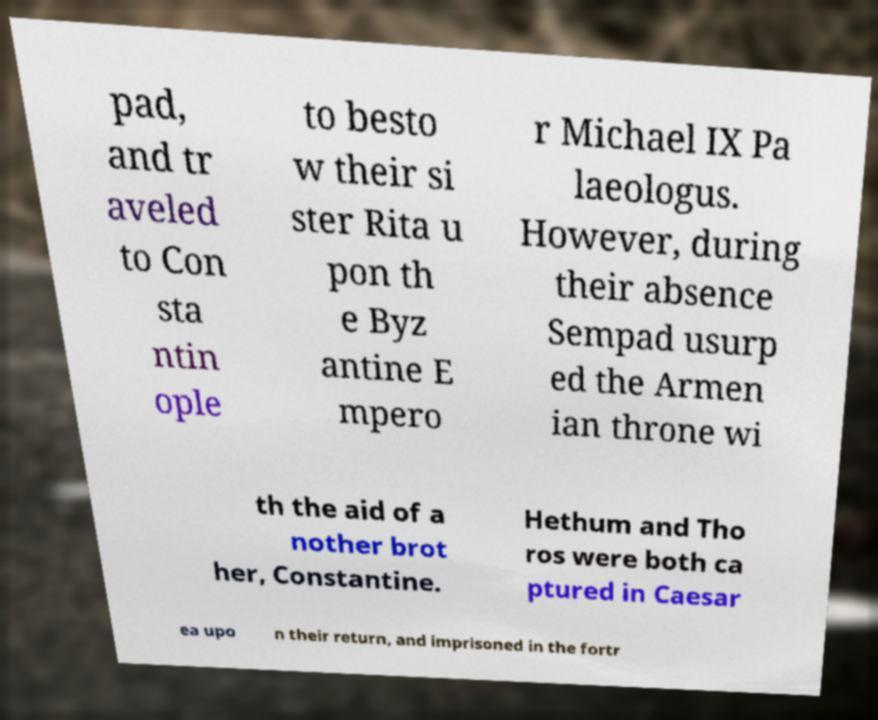Could you extract and type out the text from this image? pad, and tr aveled to Con sta ntin ople to besto w their si ster Rita u pon th e Byz antine E mpero r Michael IX Pa laeologus. However, during their absence Sempad usurp ed the Armen ian throne wi th the aid of a nother brot her, Constantine. Hethum and Tho ros were both ca ptured in Caesar ea upo n their return, and imprisoned in the fortr 